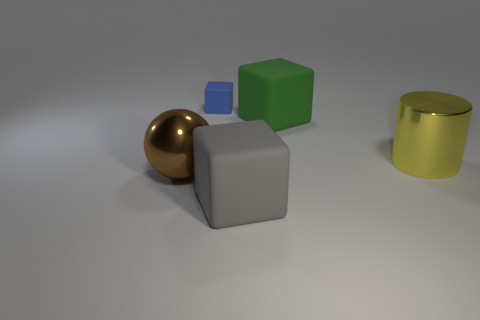Are there fewer big brown things that are in front of the metal ball than small matte objects?
Provide a succinct answer. Yes. Is there anything else that is the same size as the blue block?
Offer a very short reply. No. What is the size of the metallic thing to the right of the big matte block that is in front of the big yellow thing?
Provide a short and direct response. Large. Is there anything else that is the same shape as the brown object?
Your answer should be compact. No. Is the number of big yellow matte spheres less than the number of blue matte things?
Ensure brevity in your answer.  Yes. There is a big thing that is in front of the large green thing and behind the ball; what is its material?
Offer a terse response. Metal. Is there a big green thing that is on the right side of the large block behind the large brown sphere?
Ensure brevity in your answer.  No. How many objects are tiny cyan rubber balls or large yellow objects?
Your answer should be compact. 1. There is a thing that is behind the big brown metal thing and in front of the green matte thing; what shape is it?
Your answer should be very brief. Cylinder. Do the big thing in front of the brown shiny ball and the brown sphere have the same material?
Your answer should be compact. No. 